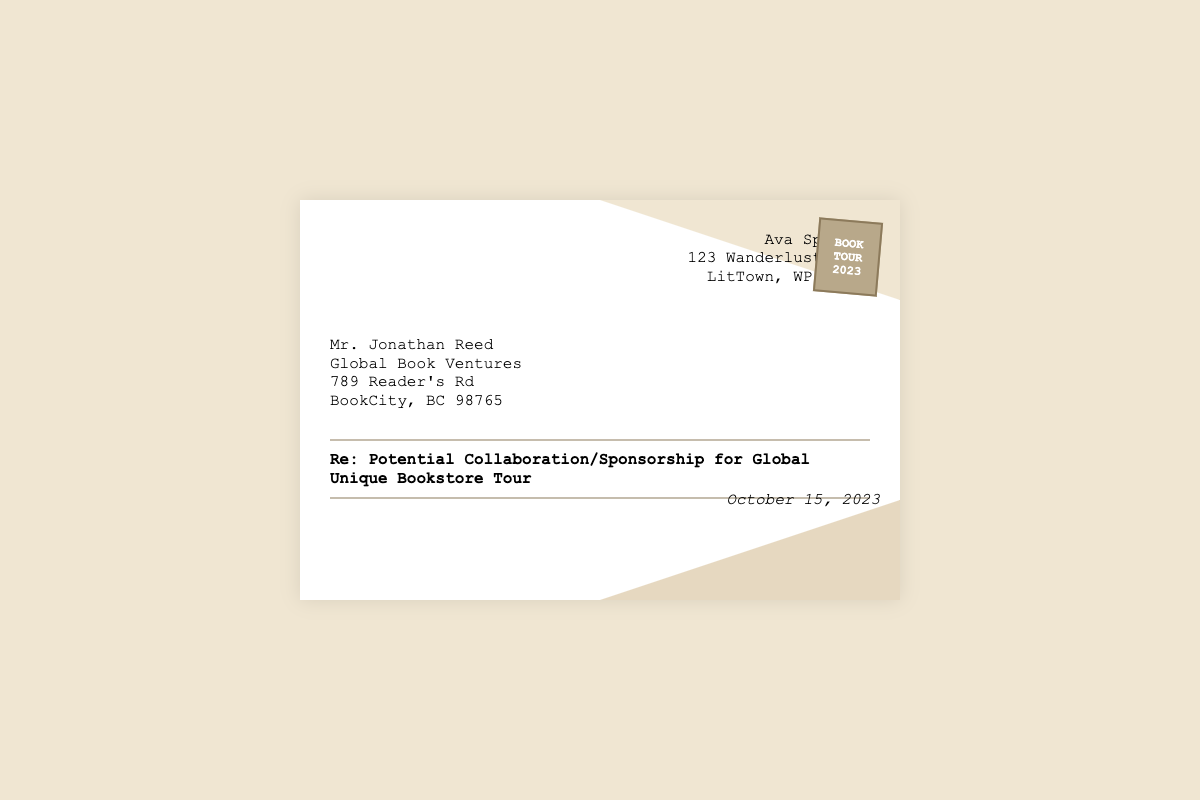what is the sender's name? The sender's name is displayed at the top of the envelope, which is Ava Spencer.
Answer: Ava Spencer what is the recipient's organization? The recipient's organization is indicated in the envelope as Global Book Ventures.
Answer: Global Book Ventures what is the date mentioned in the document? The date appears at the bottom of the envelope, noted as October 15, 2023.
Answer: October 15, 2023 what is the subject of the correspondence? The subject is outlined prominently in the envelope as Re: Potential Collaboration/Sponsorship for Global Unique Bookstore Tour.
Answer: Re: Potential Collaboration/Sponsorship for Global Unique Bookstore Tour what is the address of the sender? The sender's address is listed directly beneath the sender's name as 123 Wanderlust Lane, LitTown, WP 45678.
Answer: 123 Wanderlust Lane, LitTown, WP 45678 how many stamps are displayed? The envelope contains one stamp, showcasing the text BOOK TOUR 2023.
Answer: 1 who is the recipient of the letter? The recipient is identified as Mr. Jonathan Reed.
Answer: Mr. Jonathan Reed what is the purpose of the correspondence? The purpose is indicated in the subject line, referring to a potential collaboration or sponsorship.
Answer: potential collaboration/sponsorship what city is the sender located in? The city mentioned in the sender's address is LitTown.
Answer: LitTown 